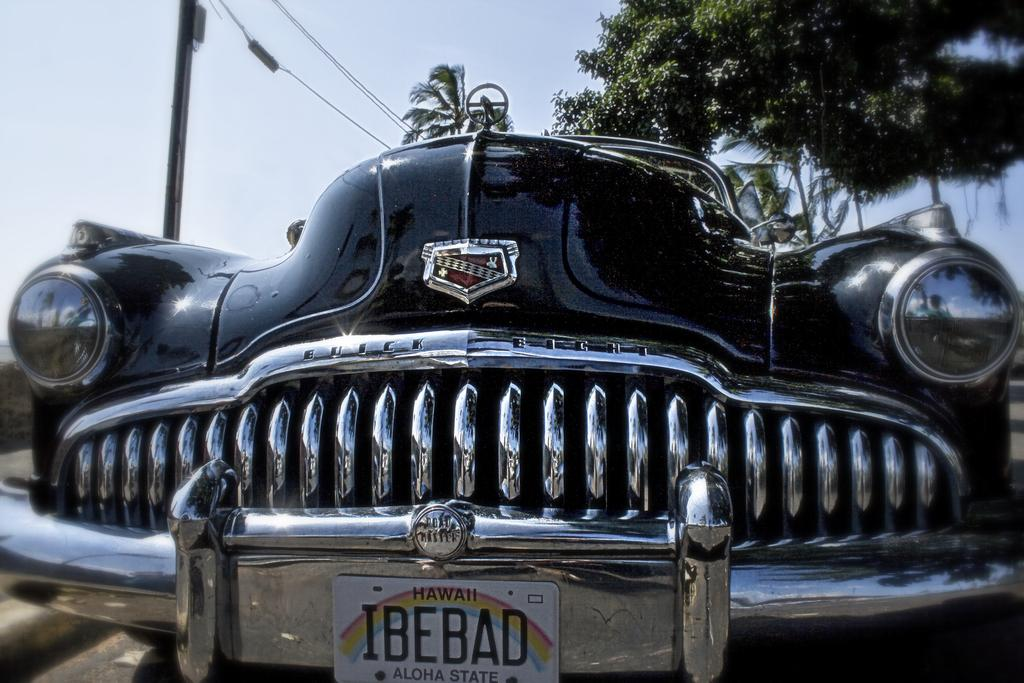What is the color of the vehicle in the image? The vehicle in the image is black-colored. What can be seen in the background of the image? There is an electric pole, wires, green-colored trees, and the sky in the background of the image. What is the color combination of the sky in the image? The sky in the image is a combination of white and blue colors. What type of grass is growing near the vehicle in the image? There is no grass visible in the image; it only shows a black-colored vehicle, an electric pole, wires, green-colored trees, and the sky in the background. 